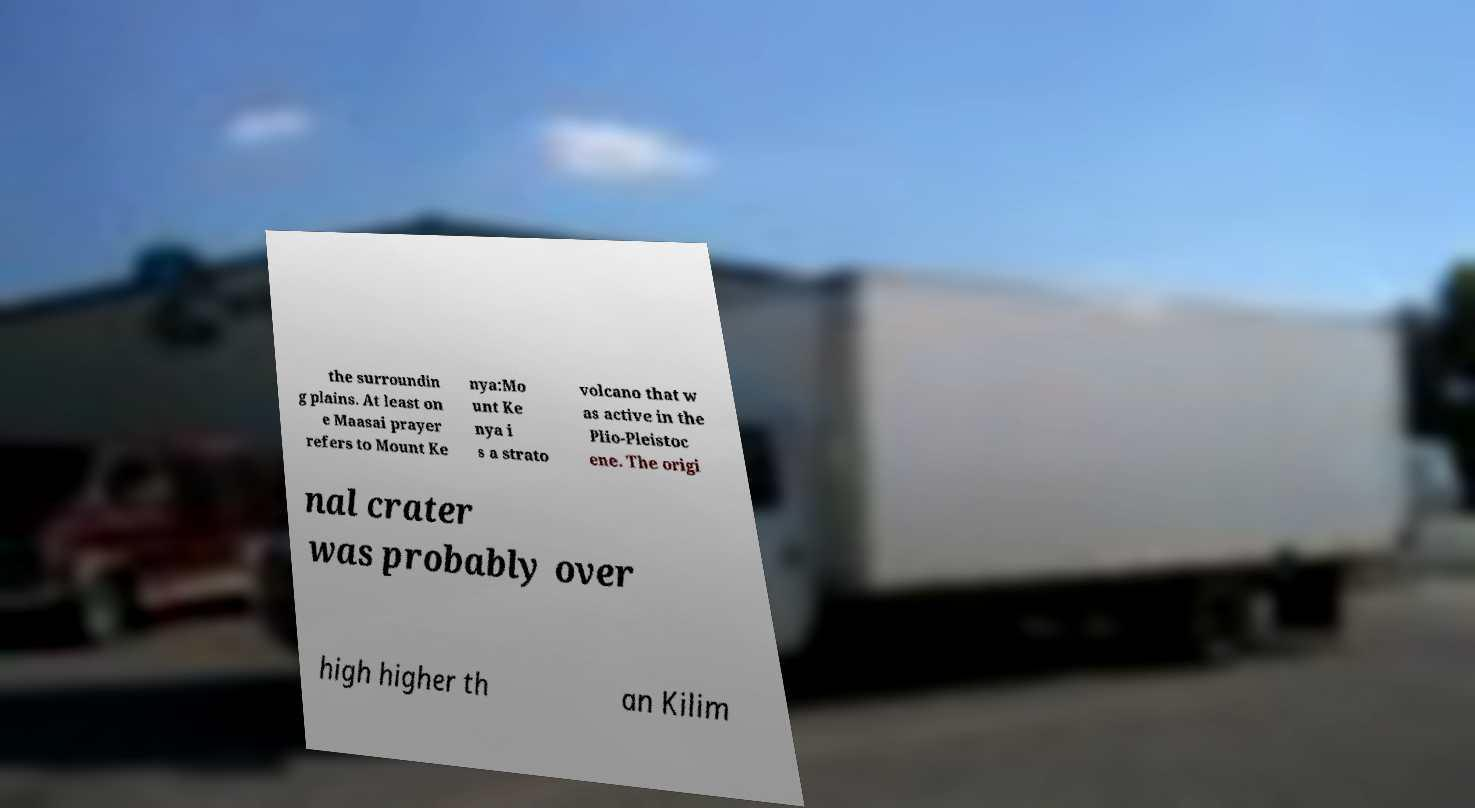Could you extract and type out the text from this image? the surroundin g plains. At least on e Maasai prayer refers to Mount Ke nya:Mo unt Ke nya i s a strato volcano that w as active in the Plio-Pleistoc ene. The origi nal crater was probably over high higher th an Kilim 